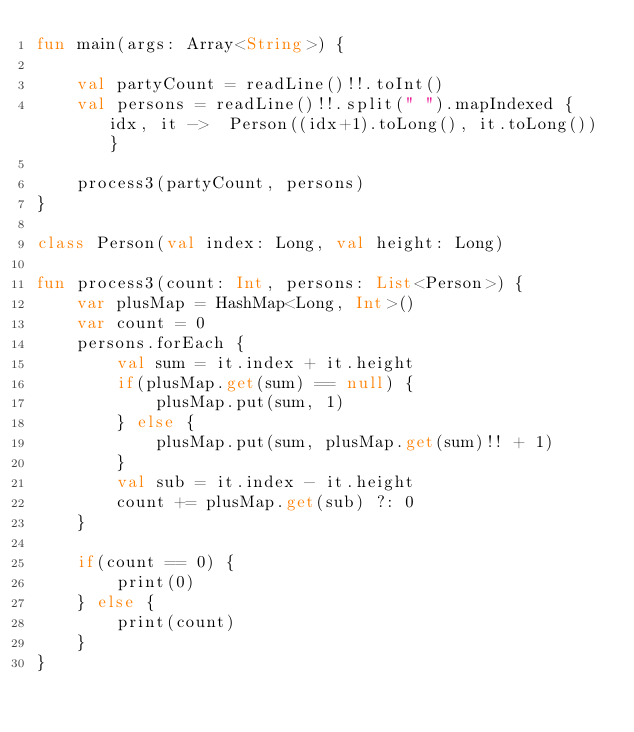<code> <loc_0><loc_0><loc_500><loc_500><_Kotlin_>fun main(args: Array<String>) {

    val partyCount = readLine()!!.toInt()
    val persons = readLine()!!.split(" ").mapIndexed { idx, it ->  Person((idx+1).toLong(), it.toLong()) }

    process3(partyCount, persons)
}

class Person(val index: Long, val height: Long)

fun process3(count: Int, persons: List<Person>) {
    var plusMap = HashMap<Long, Int>()
    var count = 0
    persons.forEach {
        val sum = it.index + it.height
        if(plusMap.get(sum) == null) {
            plusMap.put(sum, 1)
        } else {
            plusMap.put(sum, plusMap.get(sum)!! + 1)
        }
        val sub = it.index - it.height
        count += plusMap.get(sub) ?: 0
    }

    if(count == 0) {
        print(0)
    } else {
        print(count)
    }
}
</code> 